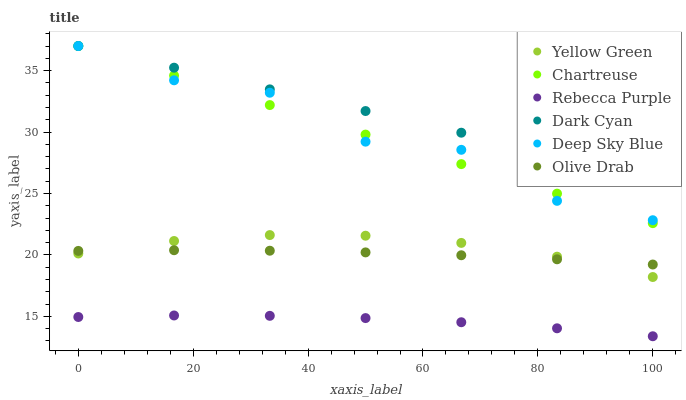Does Rebecca Purple have the minimum area under the curve?
Answer yes or no. Yes. Does Dark Cyan have the maximum area under the curve?
Answer yes or no. Yes. Does Chartreuse have the minimum area under the curve?
Answer yes or no. No. Does Chartreuse have the maximum area under the curve?
Answer yes or no. No. Is Dark Cyan the smoothest?
Answer yes or no. Yes. Is Deep Sky Blue the roughest?
Answer yes or no. Yes. Is Chartreuse the smoothest?
Answer yes or no. No. Is Chartreuse the roughest?
Answer yes or no. No. Does Rebecca Purple have the lowest value?
Answer yes or no. Yes. Does Chartreuse have the lowest value?
Answer yes or no. No. Does Dark Cyan have the highest value?
Answer yes or no. Yes. Does Rebecca Purple have the highest value?
Answer yes or no. No. Is Olive Drab less than Deep Sky Blue?
Answer yes or no. Yes. Is Chartreuse greater than Rebecca Purple?
Answer yes or no. Yes. Does Yellow Green intersect Olive Drab?
Answer yes or no. Yes. Is Yellow Green less than Olive Drab?
Answer yes or no. No. Is Yellow Green greater than Olive Drab?
Answer yes or no. No. Does Olive Drab intersect Deep Sky Blue?
Answer yes or no. No. 